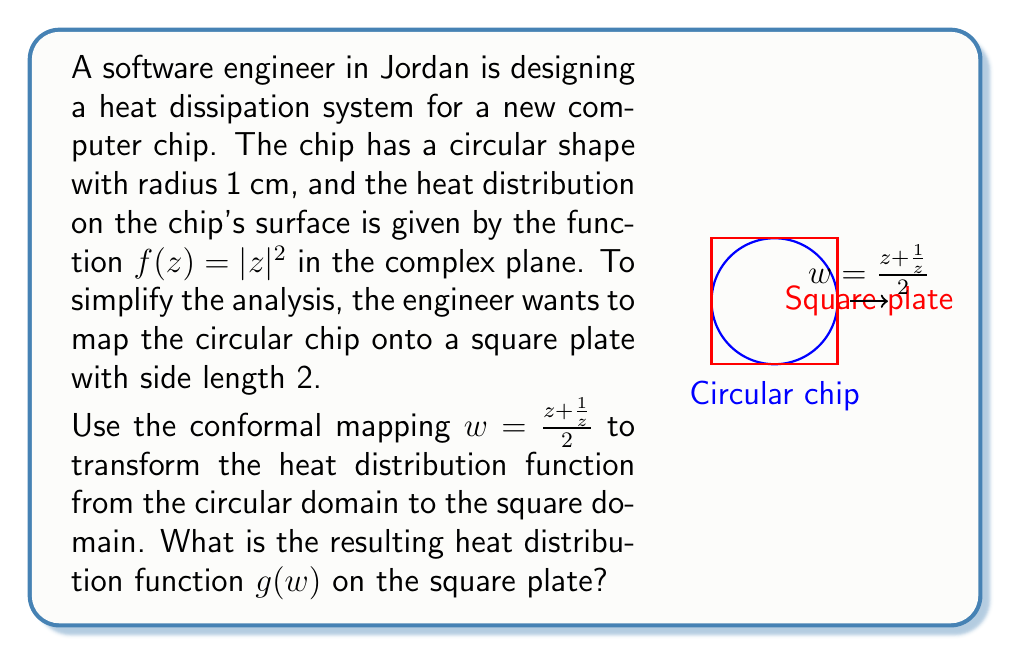What is the answer to this math problem? Let's approach this step-by-step:

1) The original heat distribution is given by $f(z) = |z|^2$ on the unit circle.

2) We need to express $z$ in terms of $w$ using the inverse of the given conformal mapping. From $w = \frac{z + \frac{1}{z}}{2}$, we can derive:

   $$z^2 - 2wz + 1 = 0$$

3) Solving this quadratic equation for $z$:

   $$z = w \pm \sqrt{w^2 - 1}$$

4) We choose the "+" solution as it maps the exterior of the unit circle to the exterior of the square:

   $$z = w + \sqrt{w^2 - 1}$$

5) Now, we need to express $|z|^2$ in terms of $w$:

   $$|z|^2 = (w + \sqrt{w^2 - 1})(w^* + \sqrt{(w^*)^2 - 1})$$

   where $w^*$ is the complex conjugate of $w$.

6) Expanding this:

   $$|z|^2 = |w|^2 + 1 + w\sqrt{(w^*)^2 - 1} + w^*\sqrt{w^2 - 1}$$

7) On the square boundary, $w$ is real, so $w = w^*$ and $\sqrt{w^2 - 1}$ is purely imaginary. Therefore, the last two terms cancel out:

   $$g(w) = |w|^2 + 1$$

This is the resulting heat distribution function on the square plate.
Answer: $g(w) = |w|^2 + 1$ 